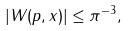Convert formula to latex. <formula><loc_0><loc_0><loc_500><loc_500>| W ( p , x ) | \leq \pi ^ { - 3 } ,</formula> 